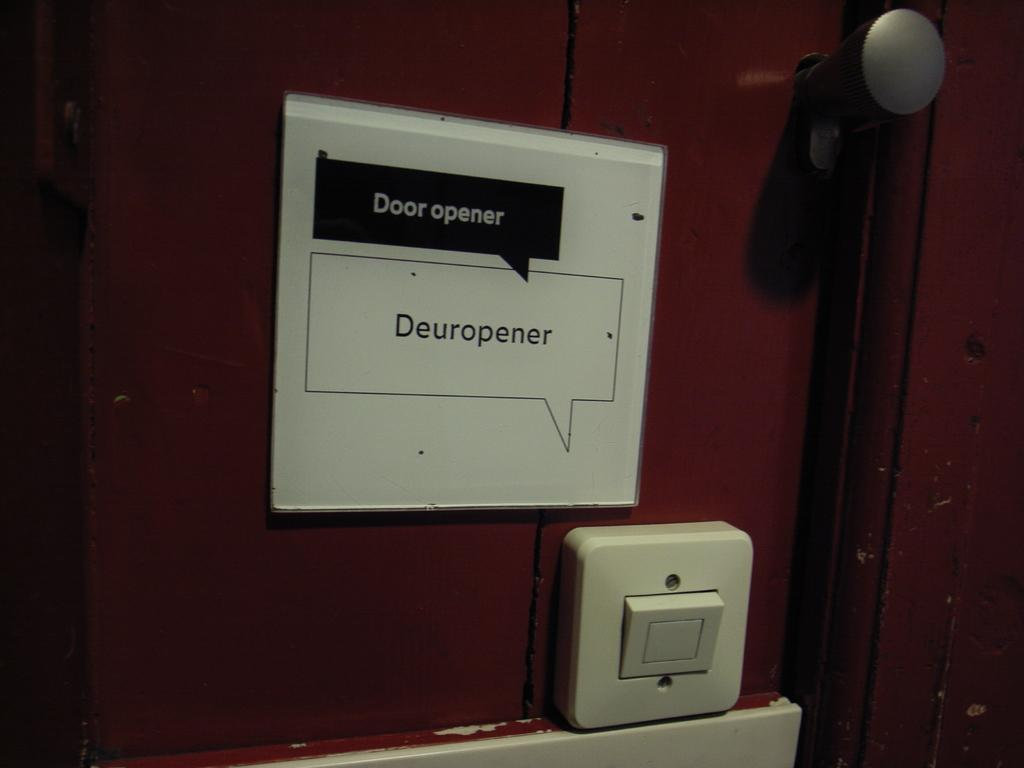<image>
Render a clear and concise summary of the photo. A switch and a small sign that says Door opener and Deuropener. 